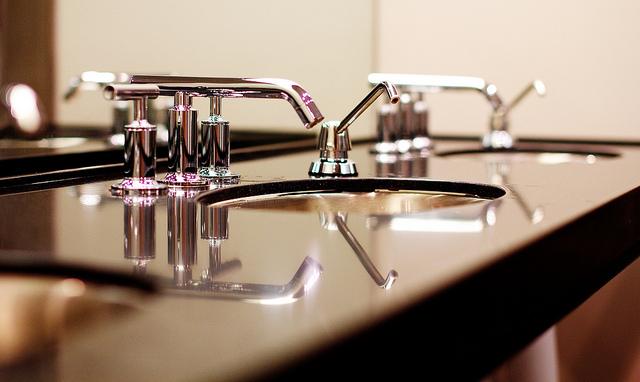Is this metal?
Write a very short answer. Yes. How many sinks are displayed?
Be succinct. 2. What object is this?
Keep it brief. Sink. 